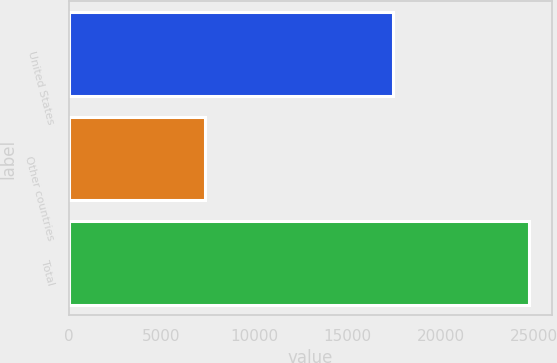Convert chart to OTSL. <chart><loc_0><loc_0><loc_500><loc_500><bar_chart><fcel>United States<fcel>Other countries<fcel>Total<nl><fcel>17409.4<fcel>7310.1<fcel>24719.5<nl></chart> 